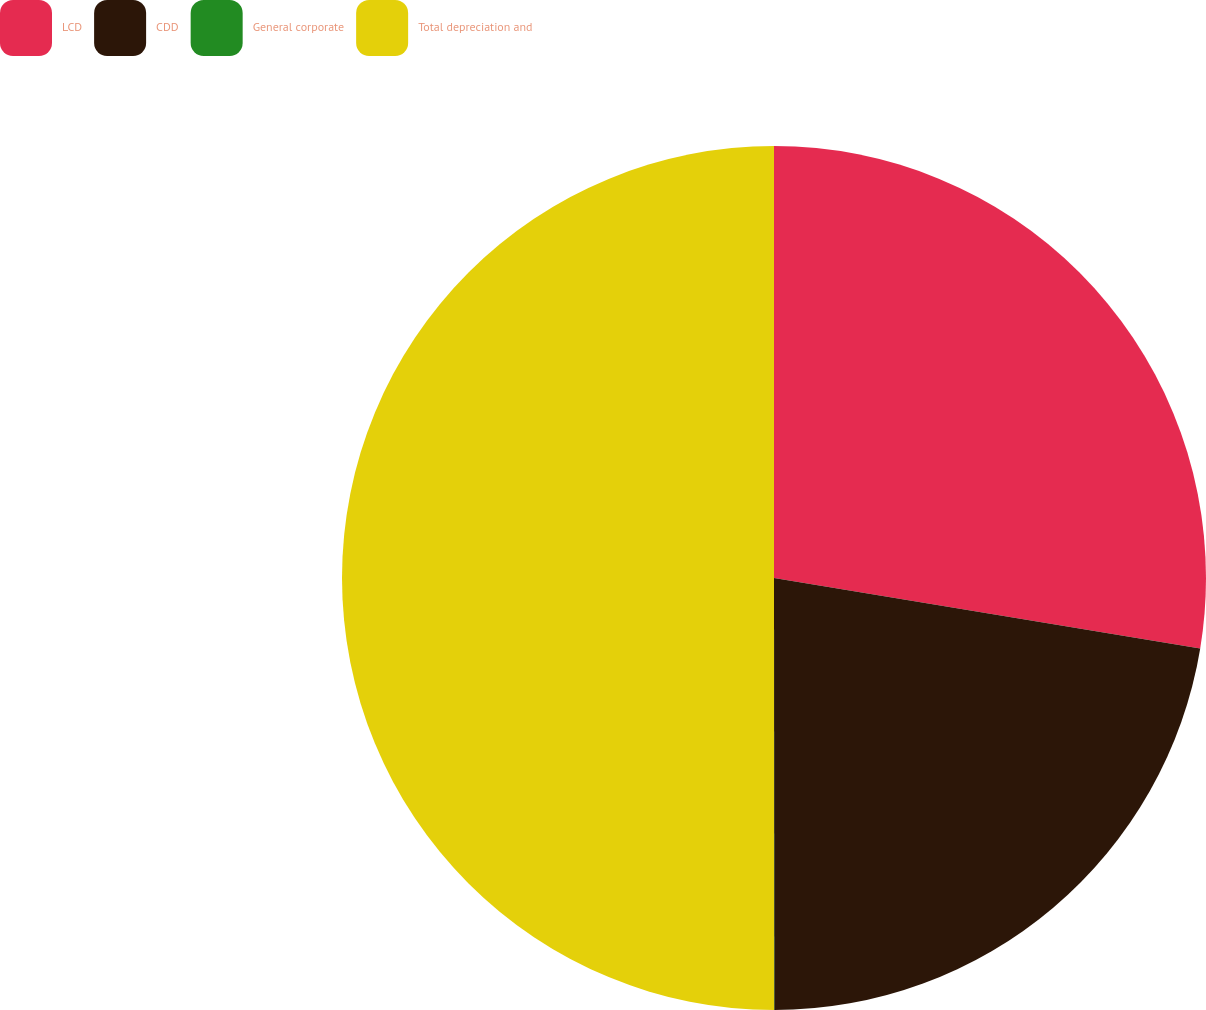Convert chart. <chart><loc_0><loc_0><loc_500><loc_500><pie_chart><fcel>LCD<fcel>CDD<fcel>General corporate<fcel>Total depreciation and<nl><fcel>27.61%<fcel>22.38%<fcel>0.01%<fcel>50.0%<nl></chart> 